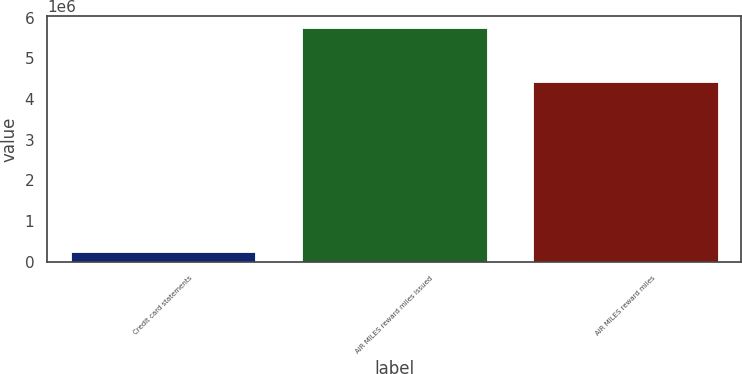Convert chart. <chart><loc_0><loc_0><loc_500><loc_500><bar_chart><fcel>Credit card statements<fcel>AIR MILES reward miles issued<fcel>AIR MILES reward miles<nl><fcel>242266<fcel>5.7431e+06<fcel>4.40629e+06<nl></chart> 